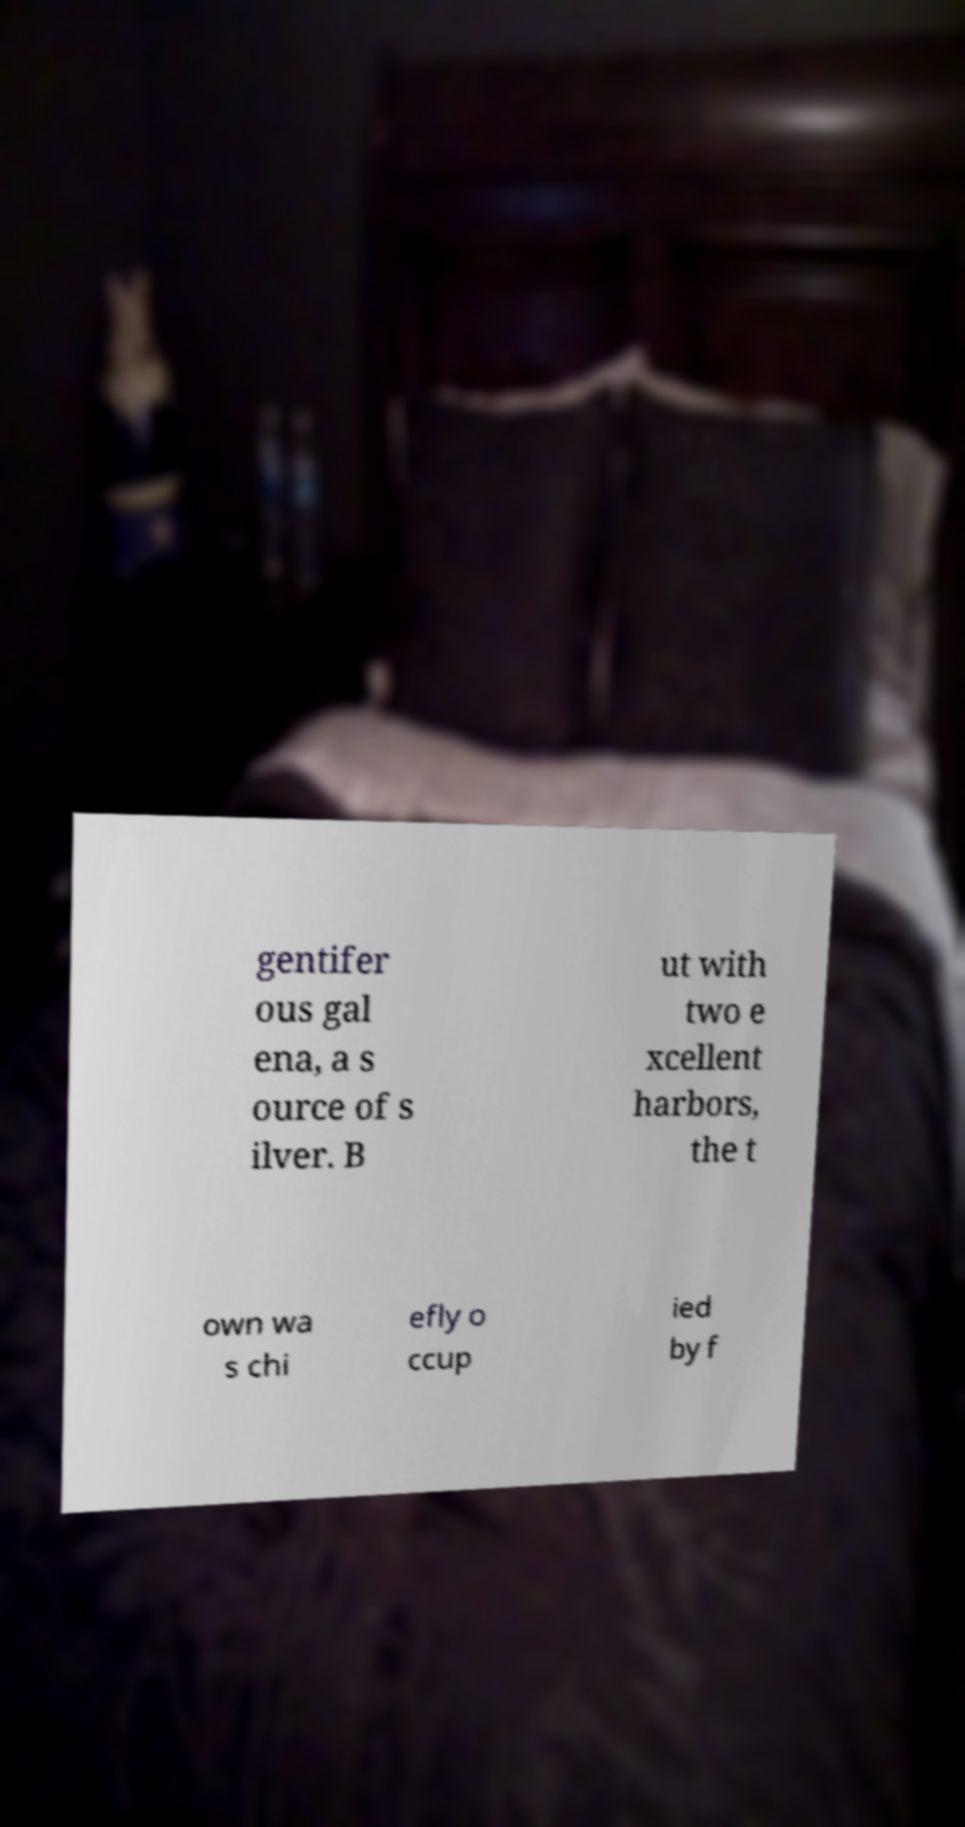There's text embedded in this image that I need extracted. Can you transcribe it verbatim? gentifer ous gal ena, a s ource of s ilver. B ut with two e xcellent harbors, the t own wa s chi efly o ccup ied by f 